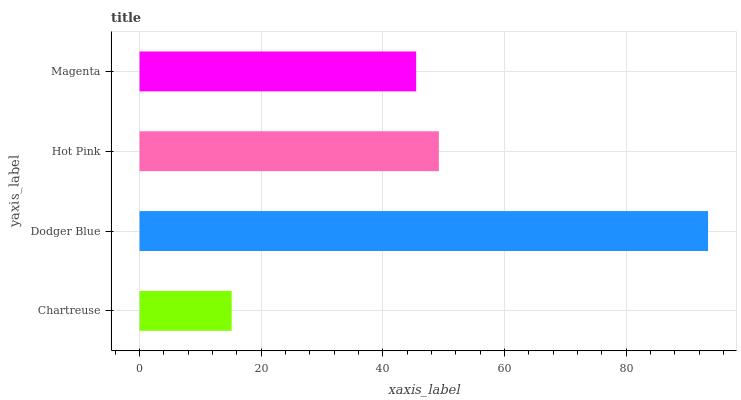Is Chartreuse the minimum?
Answer yes or no. Yes. Is Dodger Blue the maximum?
Answer yes or no. Yes. Is Hot Pink the minimum?
Answer yes or no. No. Is Hot Pink the maximum?
Answer yes or no. No. Is Dodger Blue greater than Hot Pink?
Answer yes or no. Yes. Is Hot Pink less than Dodger Blue?
Answer yes or no. Yes. Is Hot Pink greater than Dodger Blue?
Answer yes or no. No. Is Dodger Blue less than Hot Pink?
Answer yes or no. No. Is Hot Pink the high median?
Answer yes or no. Yes. Is Magenta the low median?
Answer yes or no. Yes. Is Chartreuse the high median?
Answer yes or no. No. Is Hot Pink the low median?
Answer yes or no. No. 